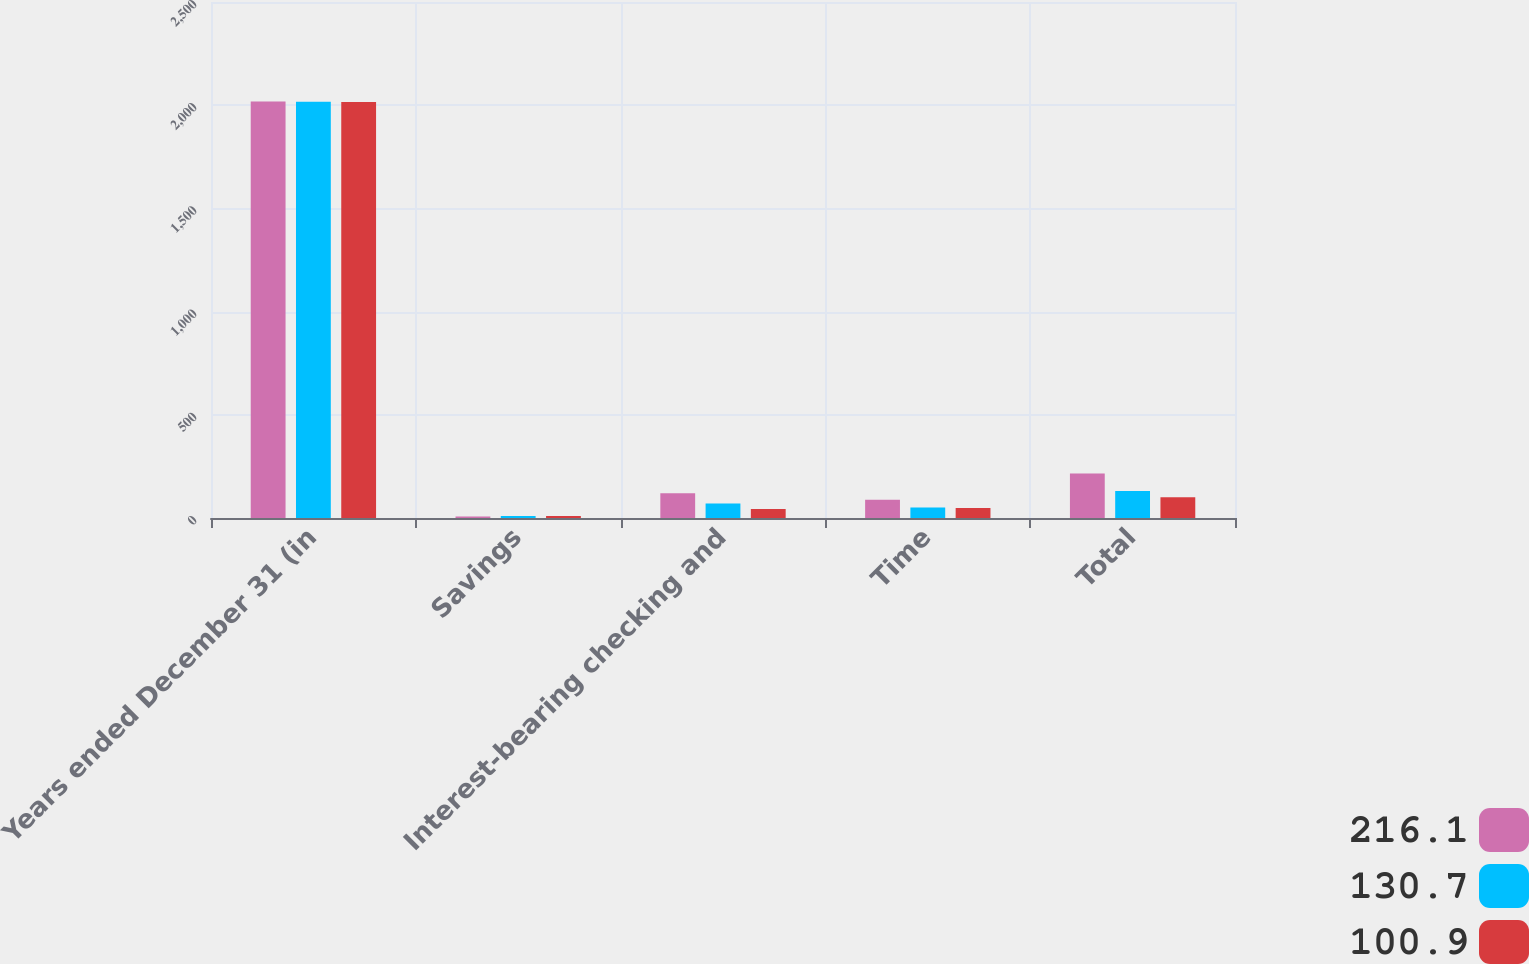<chart> <loc_0><loc_0><loc_500><loc_500><stacked_bar_chart><ecel><fcel>Years ended December 31 (in<fcel>Savings<fcel>Interest-bearing checking and<fcel>Time<fcel>Total<nl><fcel>216.1<fcel>2018<fcel>7.2<fcel>120.2<fcel>88.7<fcel>216.1<nl><fcel>130.7<fcel>2017<fcel>9.7<fcel>70.4<fcel>50.6<fcel>130.7<nl><fcel>100.9<fcel>2016<fcel>9.6<fcel>43.4<fcel>47.9<fcel>100.9<nl></chart> 